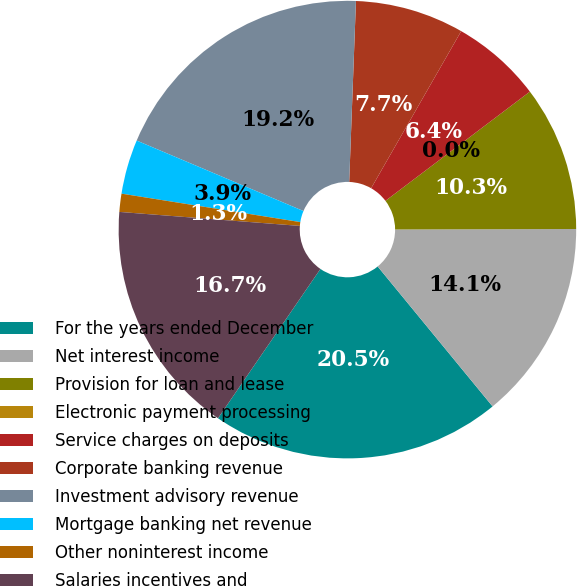Convert chart. <chart><loc_0><loc_0><loc_500><loc_500><pie_chart><fcel>For the years ended December<fcel>Net interest income<fcel>Provision for loan and lease<fcel>Electronic payment processing<fcel>Service charges on deposits<fcel>Corporate banking revenue<fcel>Investment advisory revenue<fcel>Mortgage banking net revenue<fcel>Other noninterest income<fcel>Salaries incentives and<nl><fcel>20.51%<fcel>14.1%<fcel>10.26%<fcel>0.0%<fcel>6.41%<fcel>7.69%<fcel>19.23%<fcel>3.85%<fcel>1.28%<fcel>16.66%<nl></chart> 